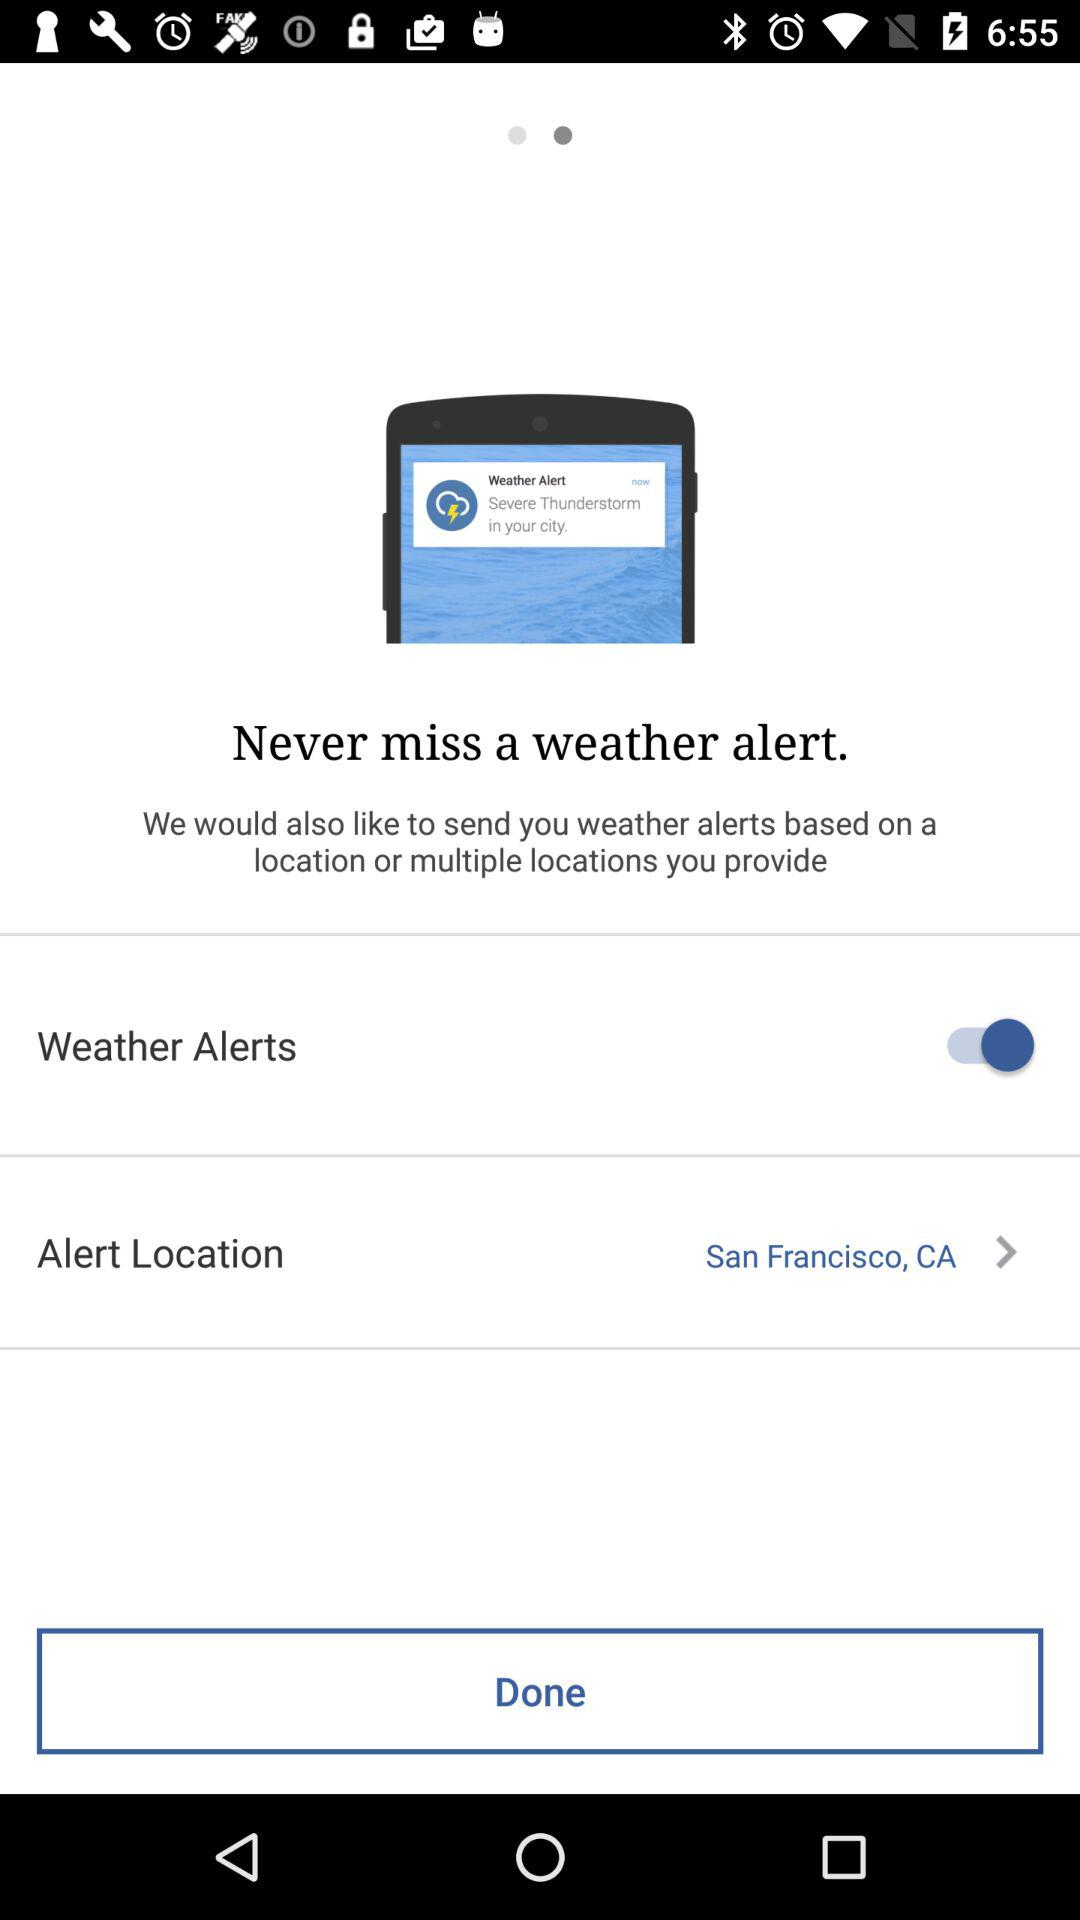What is the alert location? The alert location is San Francisco, CA. 